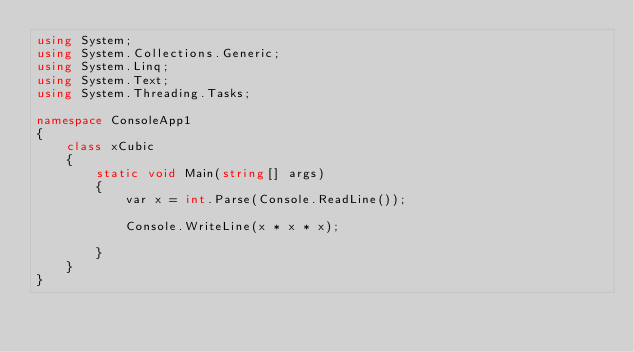Convert code to text. <code><loc_0><loc_0><loc_500><loc_500><_C#_>using System;
using System.Collections.Generic;
using System.Linq;
using System.Text;
using System.Threading.Tasks;

namespace ConsoleApp1
{
    class xCubic
    {
        static void Main(string[] args)
        {
            var x = int.Parse(Console.ReadLine());

            Console.WriteLine(x * x * x);

        }
    }
}

</code> 